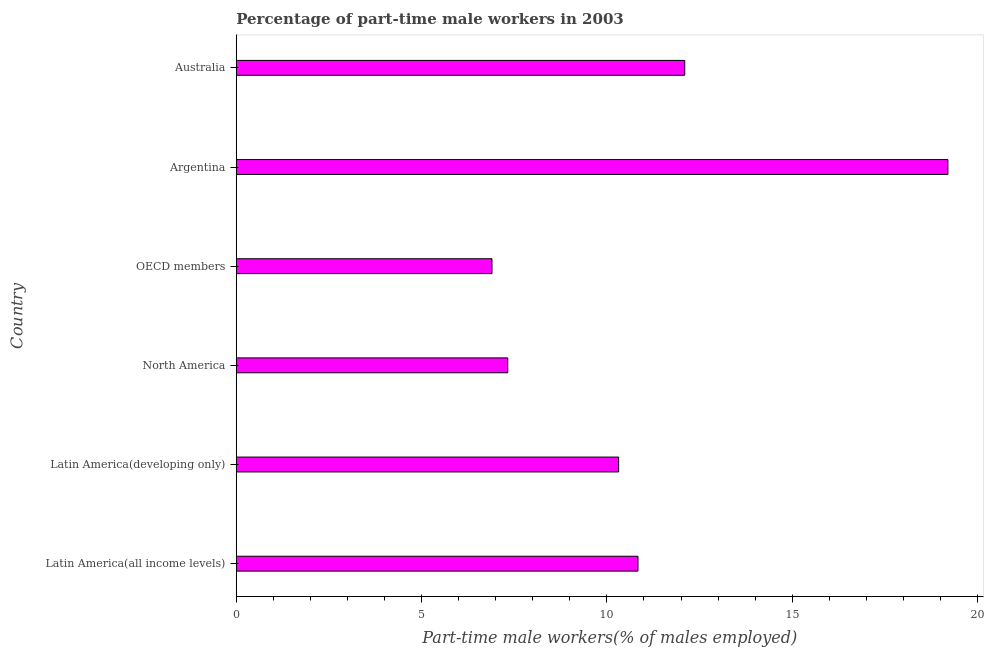What is the title of the graph?
Ensure brevity in your answer.  Percentage of part-time male workers in 2003. What is the label or title of the X-axis?
Provide a succinct answer. Part-time male workers(% of males employed). What is the label or title of the Y-axis?
Offer a terse response. Country. What is the percentage of part-time male workers in Argentina?
Offer a very short reply. 19.2. Across all countries, what is the maximum percentage of part-time male workers?
Offer a terse response. 19.2. Across all countries, what is the minimum percentage of part-time male workers?
Provide a short and direct response. 6.9. In which country was the percentage of part-time male workers maximum?
Keep it short and to the point. Argentina. In which country was the percentage of part-time male workers minimum?
Offer a very short reply. OECD members. What is the sum of the percentage of part-time male workers?
Provide a succinct answer. 66.68. What is the difference between the percentage of part-time male workers in Argentina and North America?
Your response must be concise. 11.88. What is the average percentage of part-time male workers per country?
Provide a short and direct response. 11.11. What is the median percentage of part-time male workers?
Provide a succinct answer. 10.58. What is the ratio of the percentage of part-time male workers in Australia to that in Latin America(all income levels)?
Offer a very short reply. 1.12. Is the percentage of part-time male workers in Latin America(developing only) less than that in OECD members?
Make the answer very short. No. Is the difference between the percentage of part-time male workers in Argentina and Australia greater than the difference between any two countries?
Your response must be concise. No. Is the sum of the percentage of part-time male workers in Argentina and OECD members greater than the maximum percentage of part-time male workers across all countries?
Provide a short and direct response. Yes. What is the difference between the highest and the lowest percentage of part-time male workers?
Make the answer very short. 12.3. How many bars are there?
Make the answer very short. 6. Are all the bars in the graph horizontal?
Offer a terse response. Yes. How many countries are there in the graph?
Offer a terse response. 6. What is the difference between two consecutive major ticks on the X-axis?
Offer a terse response. 5. What is the Part-time male workers(% of males employed) of Latin America(all income levels)?
Make the answer very short. 10.84. What is the Part-time male workers(% of males employed) of Latin America(developing only)?
Make the answer very short. 10.32. What is the Part-time male workers(% of males employed) in North America?
Provide a succinct answer. 7.33. What is the Part-time male workers(% of males employed) in OECD members?
Keep it short and to the point. 6.9. What is the Part-time male workers(% of males employed) in Argentina?
Offer a terse response. 19.2. What is the Part-time male workers(% of males employed) of Australia?
Your answer should be very brief. 12.1. What is the difference between the Part-time male workers(% of males employed) in Latin America(all income levels) and Latin America(developing only)?
Offer a terse response. 0.52. What is the difference between the Part-time male workers(% of males employed) in Latin America(all income levels) and North America?
Offer a very short reply. 3.51. What is the difference between the Part-time male workers(% of males employed) in Latin America(all income levels) and OECD members?
Provide a succinct answer. 3.94. What is the difference between the Part-time male workers(% of males employed) in Latin America(all income levels) and Argentina?
Your response must be concise. -8.36. What is the difference between the Part-time male workers(% of males employed) in Latin America(all income levels) and Australia?
Your answer should be very brief. -1.26. What is the difference between the Part-time male workers(% of males employed) in Latin America(developing only) and North America?
Make the answer very short. 2.99. What is the difference between the Part-time male workers(% of males employed) in Latin America(developing only) and OECD members?
Offer a terse response. 3.42. What is the difference between the Part-time male workers(% of males employed) in Latin America(developing only) and Argentina?
Offer a terse response. -8.88. What is the difference between the Part-time male workers(% of males employed) in Latin America(developing only) and Australia?
Offer a very short reply. -1.78. What is the difference between the Part-time male workers(% of males employed) in North America and OECD members?
Give a very brief answer. 0.43. What is the difference between the Part-time male workers(% of males employed) in North America and Argentina?
Provide a short and direct response. -11.87. What is the difference between the Part-time male workers(% of males employed) in North America and Australia?
Provide a short and direct response. -4.77. What is the difference between the Part-time male workers(% of males employed) in OECD members and Argentina?
Your response must be concise. -12.3. What is the difference between the Part-time male workers(% of males employed) in OECD members and Australia?
Your answer should be very brief. -5.2. What is the difference between the Part-time male workers(% of males employed) in Argentina and Australia?
Provide a short and direct response. 7.1. What is the ratio of the Part-time male workers(% of males employed) in Latin America(all income levels) to that in Latin America(developing only)?
Keep it short and to the point. 1.05. What is the ratio of the Part-time male workers(% of males employed) in Latin America(all income levels) to that in North America?
Give a very brief answer. 1.48. What is the ratio of the Part-time male workers(% of males employed) in Latin America(all income levels) to that in OECD members?
Your answer should be very brief. 1.57. What is the ratio of the Part-time male workers(% of males employed) in Latin America(all income levels) to that in Argentina?
Provide a succinct answer. 0.56. What is the ratio of the Part-time male workers(% of males employed) in Latin America(all income levels) to that in Australia?
Provide a short and direct response. 0.9. What is the ratio of the Part-time male workers(% of males employed) in Latin America(developing only) to that in North America?
Offer a terse response. 1.41. What is the ratio of the Part-time male workers(% of males employed) in Latin America(developing only) to that in OECD members?
Provide a succinct answer. 1.5. What is the ratio of the Part-time male workers(% of males employed) in Latin America(developing only) to that in Argentina?
Offer a terse response. 0.54. What is the ratio of the Part-time male workers(% of males employed) in Latin America(developing only) to that in Australia?
Give a very brief answer. 0.85. What is the ratio of the Part-time male workers(% of males employed) in North America to that in OECD members?
Provide a short and direct response. 1.06. What is the ratio of the Part-time male workers(% of males employed) in North America to that in Argentina?
Provide a succinct answer. 0.38. What is the ratio of the Part-time male workers(% of males employed) in North America to that in Australia?
Offer a terse response. 0.6. What is the ratio of the Part-time male workers(% of males employed) in OECD members to that in Argentina?
Your answer should be very brief. 0.36. What is the ratio of the Part-time male workers(% of males employed) in OECD members to that in Australia?
Your answer should be very brief. 0.57. What is the ratio of the Part-time male workers(% of males employed) in Argentina to that in Australia?
Your response must be concise. 1.59. 